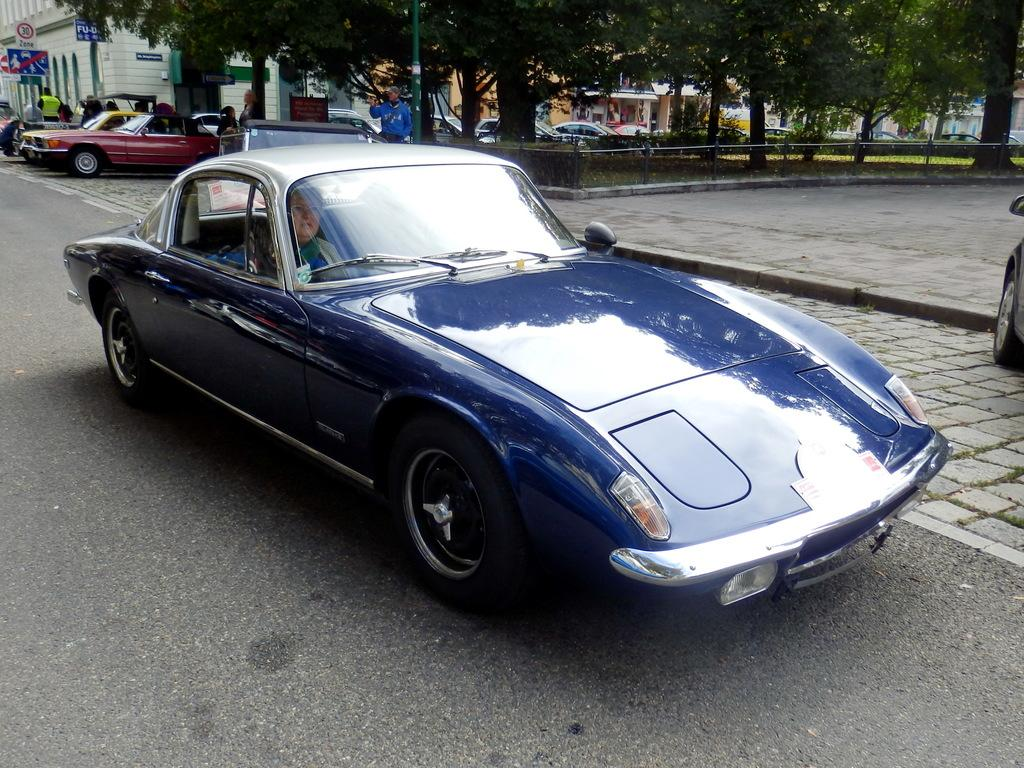What color is the car in the image? The car in the image is blue. Who is inside the car? A lady is inside the car. Where is the car located? The car is on the road. What else can be seen on the road in the image? There are other cars on the footpath. What type of vegetation is present in the image? Trees are present in the image. What can be seen in the distance in the image? Buildings are visible in the background. What rule does the dad break in the image? There is no dad present in the image, and therefore no rule-breaking can be observed. 